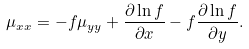Convert formula to latex. <formula><loc_0><loc_0><loc_500><loc_500>\mu _ { x x } = - f \mu _ { y y } + \frac { \partial \ln f } { \partial x } - f \frac { \partial \ln f } { \partial y } .</formula> 